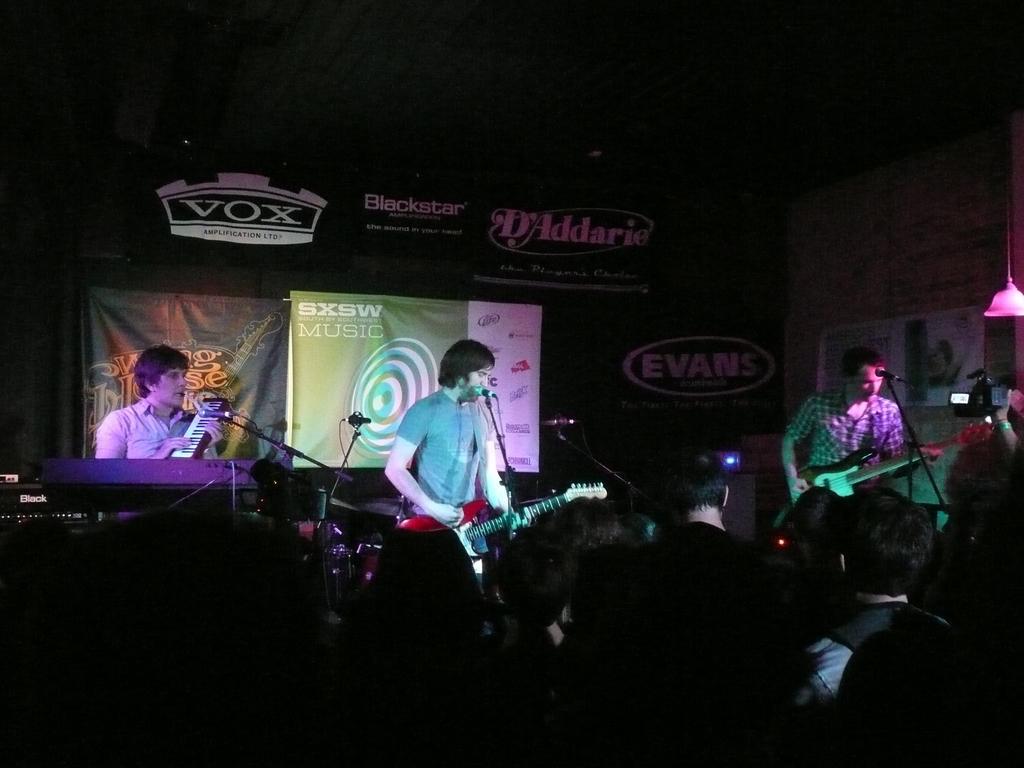Could you give a brief overview of what you see in this image? In this image we can see a person wearing a guitar. There are mics. At the bottom of the image there are people standing. In the background of the image there is banner with some text. There is a screen. At the top of the image there is ceiling. To the right side of the image there is a person standing holding a guitar. 